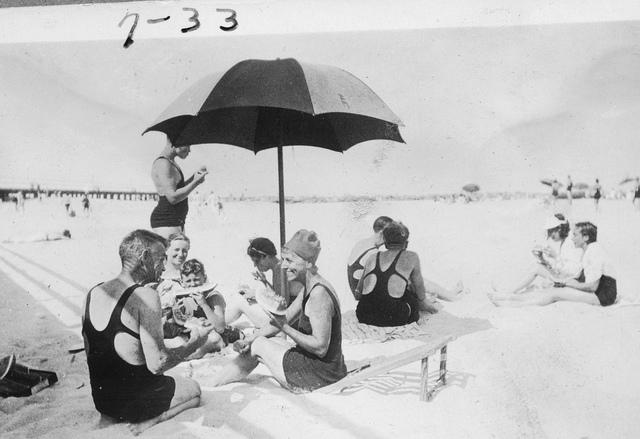Was this photo taken recently?
Give a very brief answer. No. Is the umbrella open?
Concise answer only. Yes. Is it raining?
Give a very brief answer. No. 